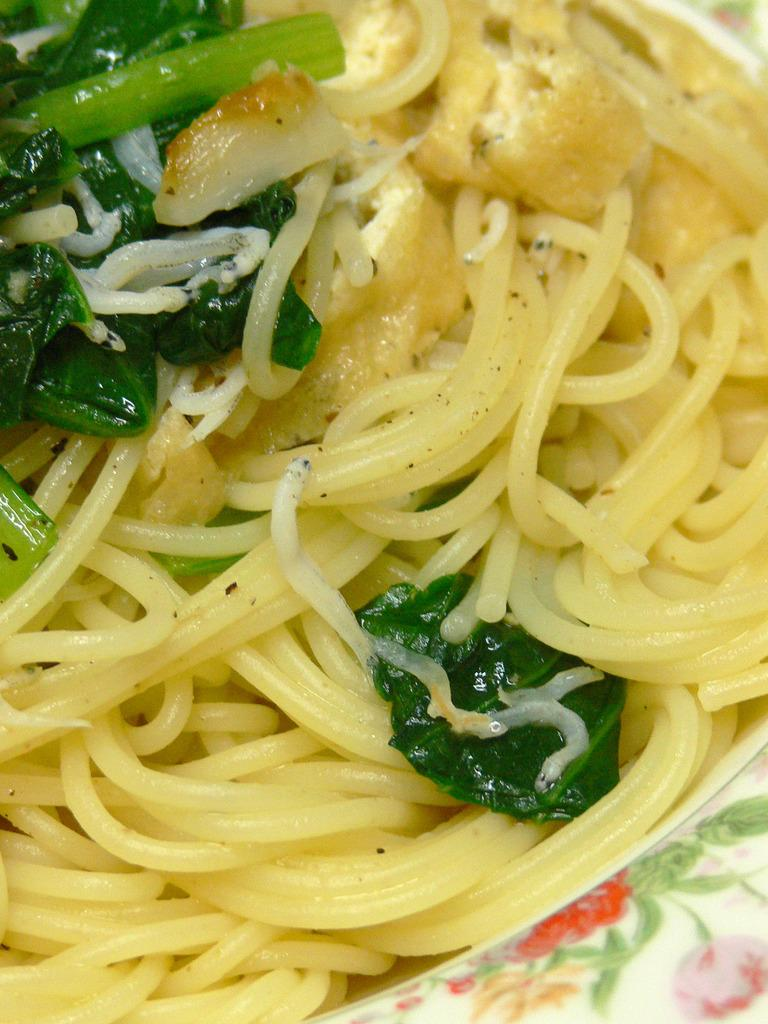What is on the plate that is visible in the image? The plate contains spaghetti and spinach. What type of food is the spaghetti served with? The spaghetti is served with spinach. What is the tendency of the seashore to be present in the image? There is no seashore present in the image; it features a plate with spaghetti and spinach. What fear is depicted in the image? There is no fear depicted in the image; it features a plate with spaghetti and spinach. 